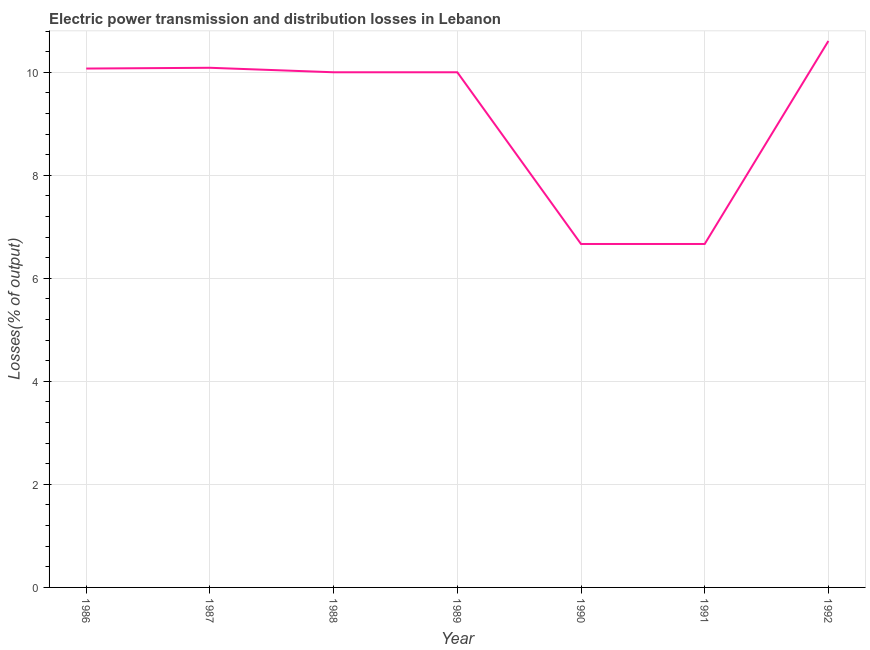What is the electric power transmission and distribution losses in 1991?
Offer a very short reply. 6.67. Across all years, what is the maximum electric power transmission and distribution losses?
Make the answer very short. 10.61. Across all years, what is the minimum electric power transmission and distribution losses?
Your answer should be compact. 6.67. In which year was the electric power transmission and distribution losses maximum?
Keep it short and to the point. 1992. What is the sum of the electric power transmission and distribution losses?
Provide a short and direct response. 64.1. What is the difference between the electric power transmission and distribution losses in 1987 and 1989?
Give a very brief answer. 0.09. What is the average electric power transmission and distribution losses per year?
Your response must be concise. 9.16. In how many years, is the electric power transmission and distribution losses greater than 8 %?
Provide a succinct answer. 5. What is the ratio of the electric power transmission and distribution losses in 1986 to that in 1987?
Your answer should be compact. 1. Is the difference between the electric power transmission and distribution losses in 1989 and 1991 greater than the difference between any two years?
Your response must be concise. No. What is the difference between the highest and the second highest electric power transmission and distribution losses?
Provide a short and direct response. 0.52. What is the difference between the highest and the lowest electric power transmission and distribution losses?
Your response must be concise. 3.94. How many lines are there?
Provide a short and direct response. 1. What is the difference between two consecutive major ticks on the Y-axis?
Provide a succinct answer. 2. Are the values on the major ticks of Y-axis written in scientific E-notation?
Make the answer very short. No. Does the graph contain grids?
Your answer should be compact. Yes. What is the title of the graph?
Offer a very short reply. Electric power transmission and distribution losses in Lebanon. What is the label or title of the X-axis?
Ensure brevity in your answer.  Year. What is the label or title of the Y-axis?
Your answer should be very brief. Losses(% of output). What is the Losses(% of output) in 1986?
Offer a very short reply. 10.07. What is the Losses(% of output) in 1987?
Give a very brief answer. 10.09. What is the Losses(% of output) of 1990?
Keep it short and to the point. 6.67. What is the Losses(% of output) in 1991?
Give a very brief answer. 6.67. What is the Losses(% of output) in 1992?
Your response must be concise. 10.61. What is the difference between the Losses(% of output) in 1986 and 1987?
Provide a succinct answer. -0.02. What is the difference between the Losses(% of output) in 1986 and 1988?
Provide a succinct answer. 0.07. What is the difference between the Losses(% of output) in 1986 and 1989?
Make the answer very short. 0.07. What is the difference between the Losses(% of output) in 1986 and 1990?
Your answer should be very brief. 3.41. What is the difference between the Losses(% of output) in 1986 and 1991?
Give a very brief answer. 3.41. What is the difference between the Losses(% of output) in 1986 and 1992?
Your answer should be very brief. -0.54. What is the difference between the Losses(% of output) in 1987 and 1988?
Ensure brevity in your answer.  0.09. What is the difference between the Losses(% of output) in 1987 and 1989?
Offer a terse response. 0.09. What is the difference between the Losses(% of output) in 1987 and 1990?
Provide a succinct answer. 3.42. What is the difference between the Losses(% of output) in 1987 and 1991?
Keep it short and to the point. 3.42. What is the difference between the Losses(% of output) in 1987 and 1992?
Make the answer very short. -0.52. What is the difference between the Losses(% of output) in 1988 and 1990?
Ensure brevity in your answer.  3.33. What is the difference between the Losses(% of output) in 1988 and 1991?
Ensure brevity in your answer.  3.33. What is the difference between the Losses(% of output) in 1988 and 1992?
Give a very brief answer. -0.61. What is the difference between the Losses(% of output) in 1989 and 1990?
Provide a succinct answer. 3.33. What is the difference between the Losses(% of output) in 1989 and 1991?
Keep it short and to the point. 3.33. What is the difference between the Losses(% of output) in 1989 and 1992?
Ensure brevity in your answer.  -0.61. What is the difference between the Losses(% of output) in 1990 and 1991?
Make the answer very short. 0. What is the difference between the Losses(% of output) in 1990 and 1992?
Offer a very short reply. -3.94. What is the difference between the Losses(% of output) in 1991 and 1992?
Ensure brevity in your answer.  -3.94. What is the ratio of the Losses(% of output) in 1986 to that in 1987?
Your response must be concise. 1. What is the ratio of the Losses(% of output) in 1986 to that in 1988?
Offer a terse response. 1.01. What is the ratio of the Losses(% of output) in 1986 to that in 1989?
Give a very brief answer. 1.01. What is the ratio of the Losses(% of output) in 1986 to that in 1990?
Your response must be concise. 1.51. What is the ratio of the Losses(% of output) in 1986 to that in 1991?
Ensure brevity in your answer.  1.51. What is the ratio of the Losses(% of output) in 1987 to that in 1990?
Keep it short and to the point. 1.51. What is the ratio of the Losses(% of output) in 1987 to that in 1991?
Your answer should be very brief. 1.51. What is the ratio of the Losses(% of output) in 1987 to that in 1992?
Your answer should be very brief. 0.95. What is the ratio of the Losses(% of output) in 1988 to that in 1992?
Keep it short and to the point. 0.94. What is the ratio of the Losses(% of output) in 1989 to that in 1990?
Provide a succinct answer. 1.5. What is the ratio of the Losses(% of output) in 1989 to that in 1991?
Provide a succinct answer. 1.5. What is the ratio of the Losses(% of output) in 1989 to that in 1992?
Your response must be concise. 0.94. What is the ratio of the Losses(% of output) in 1990 to that in 1991?
Give a very brief answer. 1. What is the ratio of the Losses(% of output) in 1990 to that in 1992?
Provide a short and direct response. 0.63. What is the ratio of the Losses(% of output) in 1991 to that in 1992?
Your answer should be compact. 0.63. 